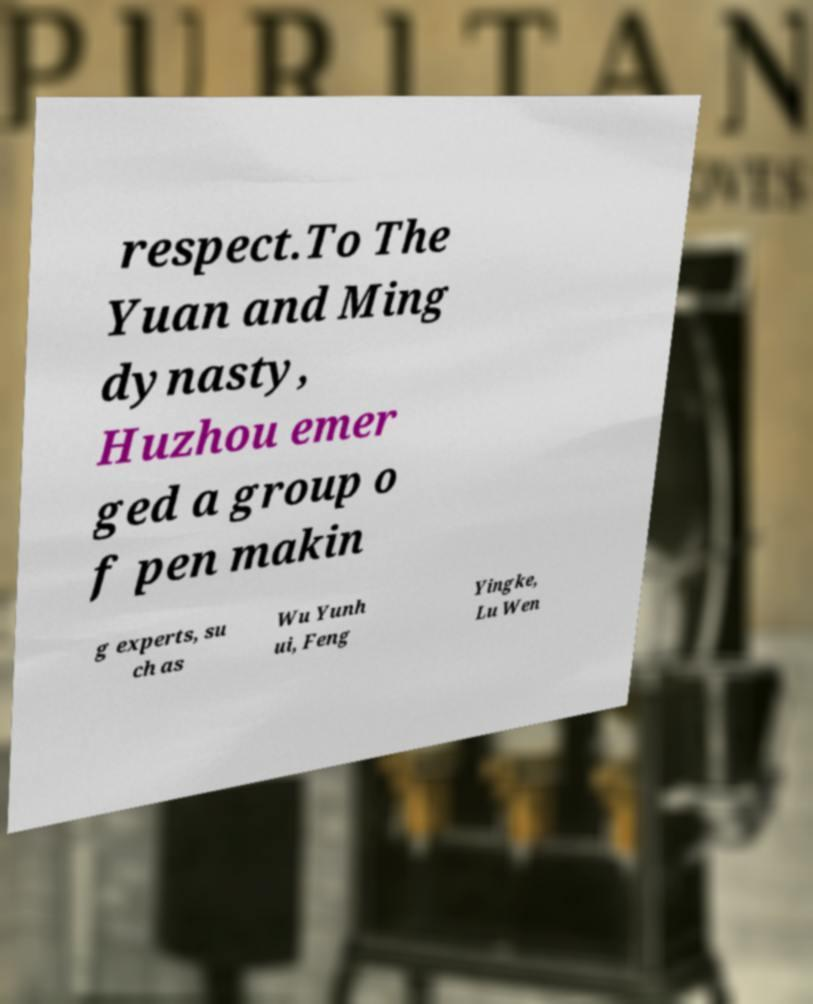Please read and relay the text visible in this image. What does it say? respect.To The Yuan and Ming dynasty, Huzhou emer ged a group o f pen makin g experts, su ch as Wu Yunh ui, Feng Yingke, Lu Wen 